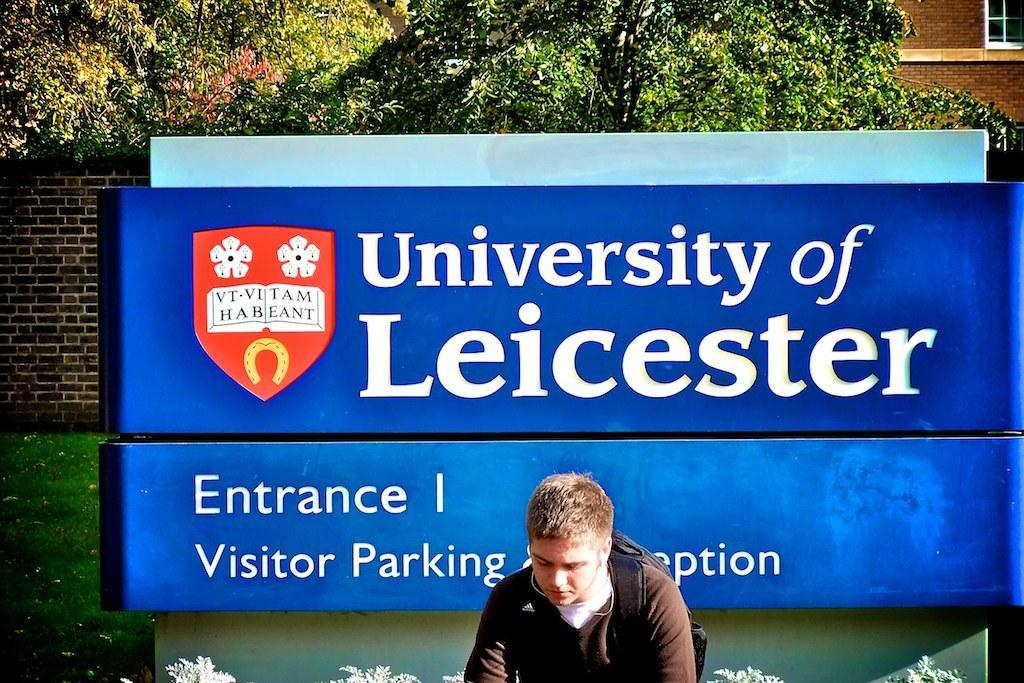<image>
Render a clear and concise summary of the photo. A young man sits in front of Entrance 1 to University of Leicester. 